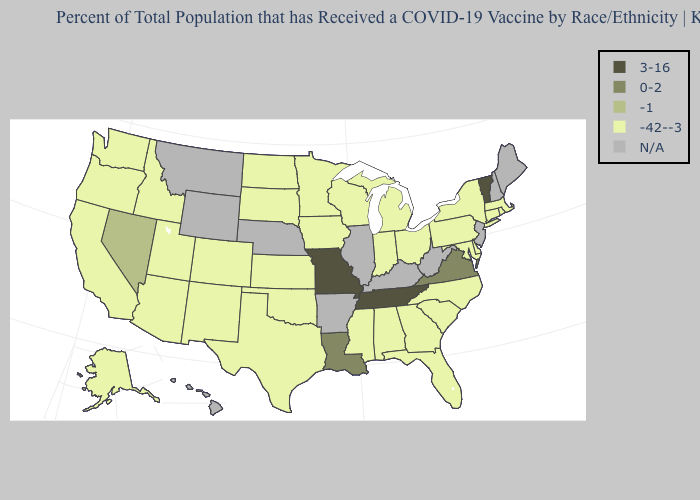What is the highest value in the USA?
Write a very short answer. 3-16. Name the states that have a value in the range 3-16?
Keep it brief. Missouri, Tennessee, Vermont. What is the value of Indiana?
Quick response, please. -42--3. Name the states that have a value in the range N/A?
Short answer required. Arkansas, Hawaii, Illinois, Kentucky, Maine, Montana, Nebraska, New Hampshire, New Jersey, West Virginia, Wyoming. Does the first symbol in the legend represent the smallest category?
Concise answer only. No. Name the states that have a value in the range 3-16?
Write a very short answer. Missouri, Tennessee, Vermont. Which states have the lowest value in the West?
Keep it brief. Alaska, Arizona, California, Colorado, Idaho, New Mexico, Oregon, Utah, Washington. What is the value of Hawaii?
Quick response, please. N/A. Which states have the lowest value in the USA?
Answer briefly. Alabama, Alaska, Arizona, California, Colorado, Connecticut, Delaware, Florida, Georgia, Idaho, Indiana, Iowa, Kansas, Maryland, Massachusetts, Michigan, Minnesota, Mississippi, New Mexico, New York, North Carolina, North Dakota, Ohio, Oklahoma, Oregon, Pennsylvania, Rhode Island, South Carolina, South Dakota, Texas, Utah, Washington, Wisconsin. Name the states that have a value in the range -42--3?
Short answer required. Alabama, Alaska, Arizona, California, Colorado, Connecticut, Delaware, Florida, Georgia, Idaho, Indiana, Iowa, Kansas, Maryland, Massachusetts, Michigan, Minnesota, Mississippi, New Mexico, New York, North Carolina, North Dakota, Ohio, Oklahoma, Oregon, Pennsylvania, Rhode Island, South Carolina, South Dakota, Texas, Utah, Washington, Wisconsin. What is the value of Illinois?
Give a very brief answer. N/A. What is the value of Michigan?
Concise answer only. -42--3. Does Vermont have the lowest value in the Northeast?
Keep it brief. No. Name the states that have a value in the range 0-2?
Keep it brief. Louisiana, Virginia. Which states hav the highest value in the West?
Write a very short answer. Nevada. 